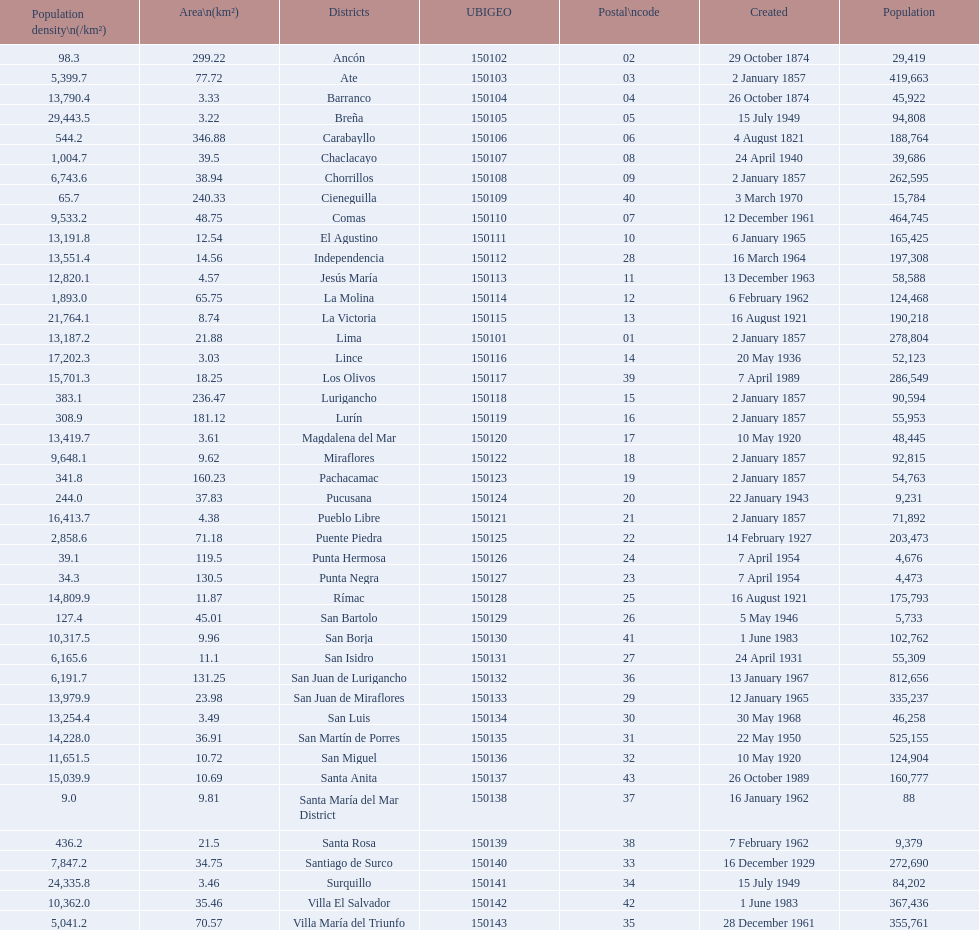What district has the least amount of population? Santa María del Mar District. 